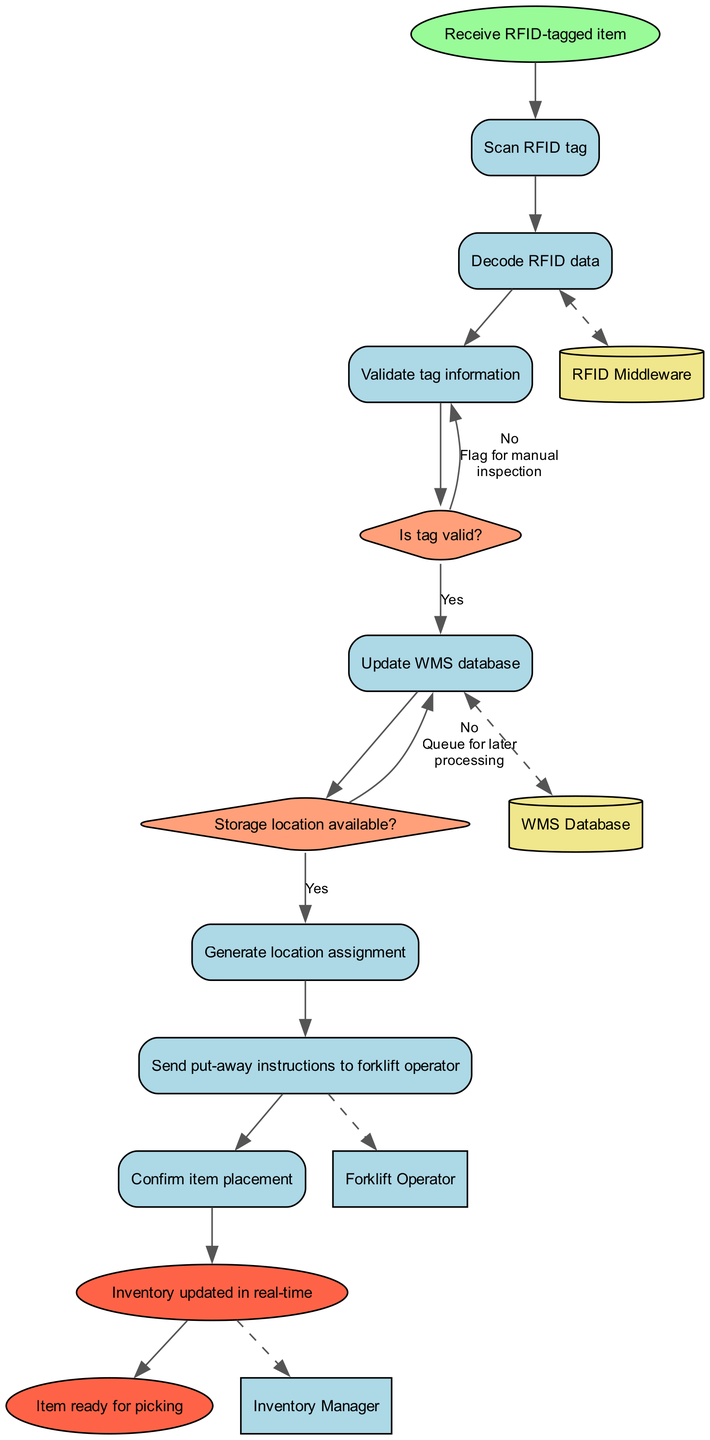What is the starting node of the diagram? The starting node is labeled "Receive RFID-tagged item," which is the first step in the activity flow.
Answer: Receive RFID-tagged item How many activities are there in the diagram? There are a total of 7 activities listed in the diagram, indicating the various tasks involved in the process.
Answer: 7 What happens if the RFID tag is not valid? If the RFID tag is not valid, the flow leads to "Flag for manual inspection," indicating that further verification is required before proceeding.
Answer: Flag for manual inspection What is generated after validating the RFID tag? After validating the RFID tag, the next action in the flow is to "Update WMS database," reflecting the importance of current information in the system.
Answer: Update WMS database Is there any interaction with external entities? Yes, there are interactions with external entities, specifically the "Forklift Operator" and the "Inventory Manager," indicating communication in the process.
Answer: Yes What occurs after the location assignment is generated? After generating the location assignment, the next step is to "Send put-away instructions to forklift operator," which involves directing the operator on where to place the item.
Answer: Send put-away instructions to forklift operator What are the conditions to generate a location assignment? The condition to generate a location assignment is dependent on whether the "Storage location available?" If yes, the system moves to generate the assignment; otherwise, it queues for later processing.
Answer: Storage location available? How many end nodes are present in the diagram? There are 2 end nodes in the diagram, "Inventory updated in real-time" and "Item ready for picking," indicating the completion of the process.
Answer: 2 What is the decision point after decoding the RFID data? The decision point following the decoding of RFID data is "Is tag valid?" which determines the subsequent steps based on tag validity.
Answer: Is tag valid? 